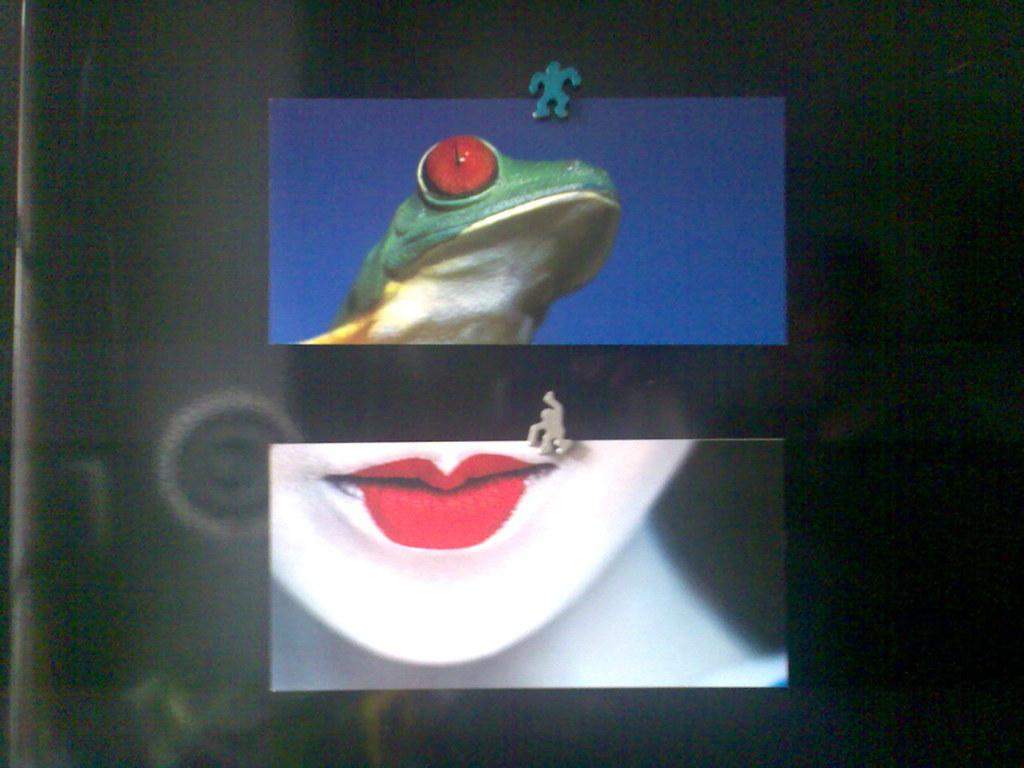What is present in the image? There are pictures in the image. How are the pictures arranged or displayed? The pictures are placed on the glass. How are the pictures secured or held in place? The pictures are held in place by pins. What type of fan is visible in the image? There is no fan present in the image. What color is the silver object in the image? There is no silver object present in the image. 